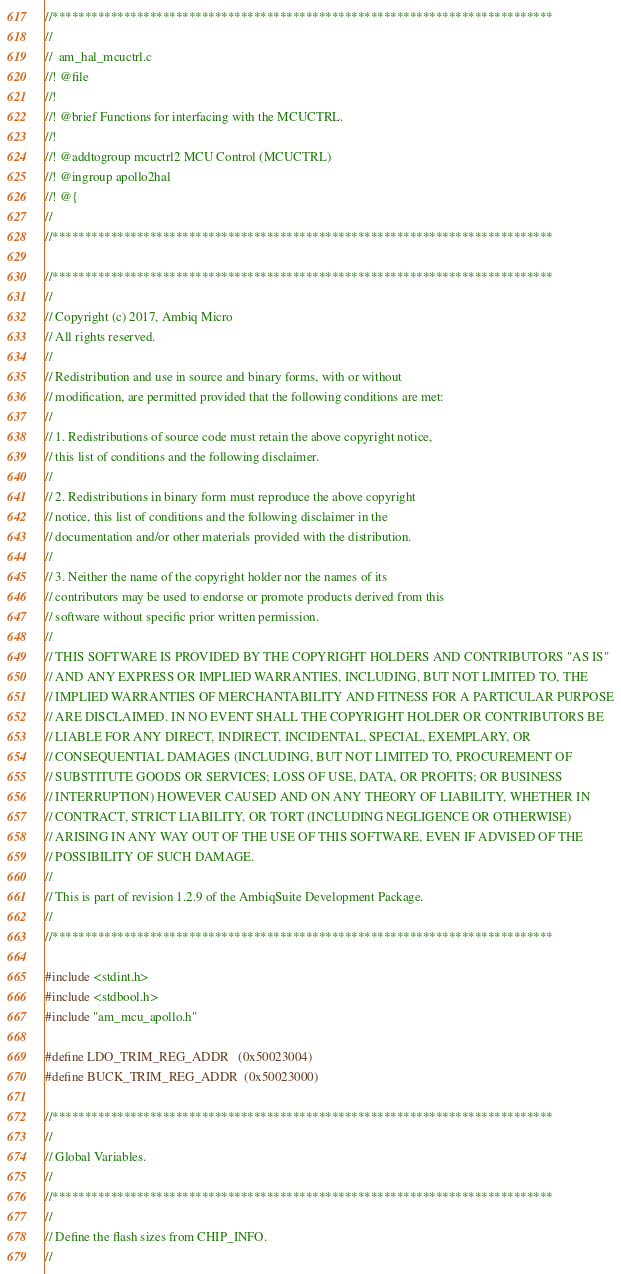<code> <loc_0><loc_0><loc_500><loc_500><_C_>//*****************************************************************************
//
//  am_hal_mcuctrl.c
//! @file
//!
//! @brief Functions for interfacing with the MCUCTRL.
//!
//! @addtogroup mcuctrl2 MCU Control (MCUCTRL)
//! @ingroup apollo2hal
//! @{
//
//*****************************************************************************

//*****************************************************************************
//
// Copyright (c) 2017, Ambiq Micro
// All rights reserved.
// 
// Redistribution and use in source and binary forms, with or without
// modification, are permitted provided that the following conditions are met:
// 
// 1. Redistributions of source code must retain the above copyright notice,
// this list of conditions and the following disclaimer.
// 
// 2. Redistributions in binary form must reproduce the above copyright
// notice, this list of conditions and the following disclaimer in the
// documentation and/or other materials provided with the distribution.
// 
// 3. Neither the name of the copyright holder nor the names of its
// contributors may be used to endorse or promote products derived from this
// software without specific prior written permission.
// 
// THIS SOFTWARE IS PROVIDED BY THE COPYRIGHT HOLDERS AND CONTRIBUTORS "AS IS"
// AND ANY EXPRESS OR IMPLIED WARRANTIES, INCLUDING, BUT NOT LIMITED TO, THE
// IMPLIED WARRANTIES OF MERCHANTABILITY AND FITNESS FOR A PARTICULAR PURPOSE
// ARE DISCLAIMED. IN NO EVENT SHALL THE COPYRIGHT HOLDER OR CONTRIBUTORS BE
// LIABLE FOR ANY DIRECT, INDIRECT, INCIDENTAL, SPECIAL, EXEMPLARY, OR
// CONSEQUENTIAL DAMAGES (INCLUDING, BUT NOT LIMITED TO, PROCUREMENT OF
// SUBSTITUTE GOODS OR SERVICES; LOSS OF USE, DATA, OR PROFITS; OR BUSINESS
// INTERRUPTION) HOWEVER CAUSED AND ON ANY THEORY OF LIABILITY, WHETHER IN
// CONTRACT, STRICT LIABILITY, OR TORT (INCLUDING NEGLIGENCE OR OTHERWISE)
// ARISING IN ANY WAY OUT OF THE USE OF THIS SOFTWARE, EVEN IF ADVISED OF THE
// POSSIBILITY OF SUCH DAMAGE.
//
// This is part of revision 1.2.9 of the AmbiqSuite Development Package.
//
//*****************************************************************************

#include <stdint.h>
#include <stdbool.h>
#include "am_mcu_apollo.h"

#define LDO_TRIM_REG_ADDR   (0x50023004)
#define BUCK_TRIM_REG_ADDR  (0x50023000)

//*****************************************************************************
//
// Global Variables.
//
//*****************************************************************************
//
// Define the flash sizes from CHIP_INFO.
//</code> 